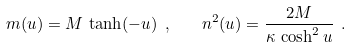<formula> <loc_0><loc_0><loc_500><loc_500>m ( u ) = M \, \tanh ( - u ) \ , \quad n ^ { 2 } ( u ) = \frac { 2 M } { \kappa \, \cosh ^ { 2 } u } \ .</formula> 